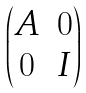Convert formula to latex. <formula><loc_0><loc_0><loc_500><loc_500>\begin{pmatrix} A & 0 \\ 0 & I \end{pmatrix}</formula> 